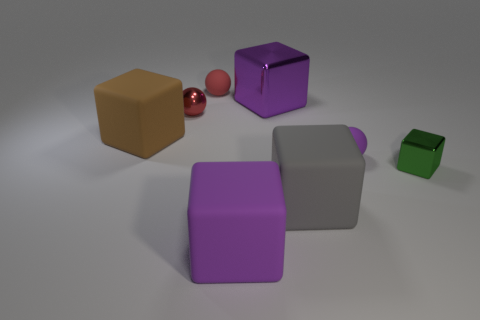Is the color of the matte sphere that is on the right side of the red matte sphere the same as the large metal cube?
Your answer should be compact. Yes. There is a tiny metal block; does it have the same color as the cube that is left of the red metallic object?
Give a very brief answer. No. Are there any tiny red rubber balls behind the small red rubber object?
Offer a terse response. No. Is the material of the large brown thing the same as the tiny block?
Offer a terse response. No. There is a brown block that is the same size as the gray cube; what material is it?
Your response must be concise. Rubber. How many things are either metallic cubes that are behind the green metal object or small purple rubber cylinders?
Offer a very short reply. 1. Is the number of tiny matte spheres that are behind the small purple matte sphere the same as the number of red objects?
Make the answer very short. No. Is the large metallic thing the same color as the small block?
Give a very brief answer. No. What color is the shiny object that is both to the left of the small green thing and to the right of the metallic sphere?
Your response must be concise. Purple. How many cylinders are either red things or big gray rubber things?
Offer a very short reply. 0. 